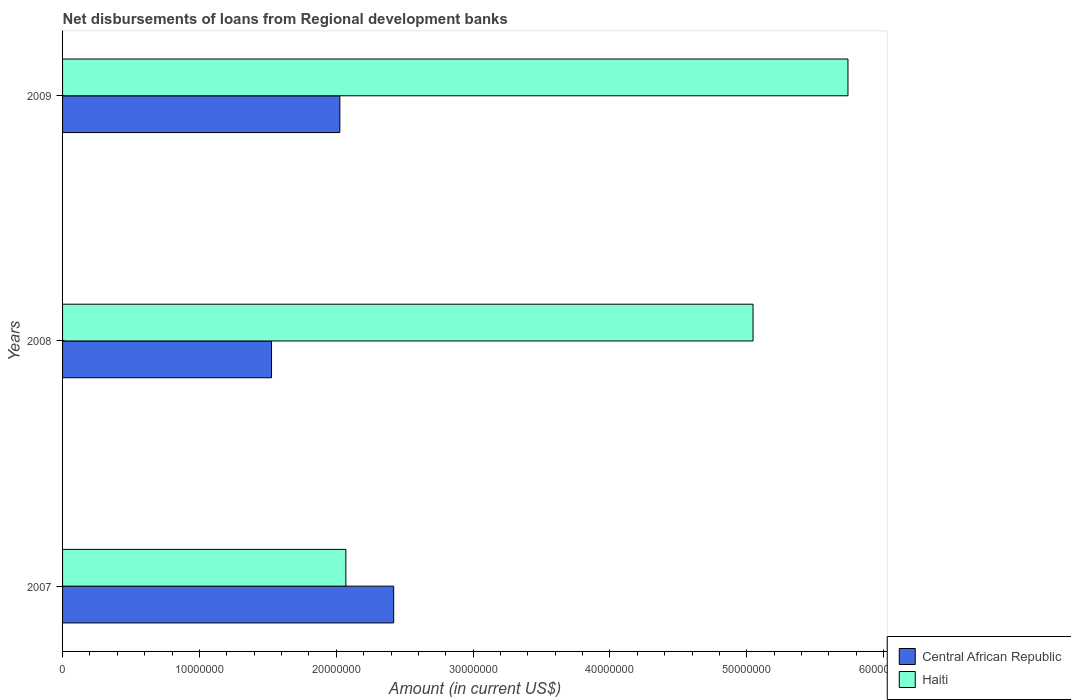Are the number of bars on each tick of the Y-axis equal?
Give a very brief answer. Yes. How many bars are there on the 3rd tick from the bottom?
Your answer should be very brief. 2. What is the label of the 3rd group of bars from the top?
Your answer should be compact. 2007. What is the amount of disbursements of loans from regional development banks in Haiti in 2009?
Make the answer very short. 5.74e+07. Across all years, what is the maximum amount of disbursements of loans from regional development banks in Central African Republic?
Offer a very short reply. 2.42e+07. Across all years, what is the minimum amount of disbursements of loans from regional development banks in Central African Republic?
Give a very brief answer. 1.53e+07. In which year was the amount of disbursements of loans from regional development banks in Central African Republic minimum?
Keep it short and to the point. 2008. What is the total amount of disbursements of loans from regional development banks in Haiti in the graph?
Offer a very short reply. 1.29e+08. What is the difference between the amount of disbursements of loans from regional development banks in Central African Republic in 2007 and that in 2009?
Ensure brevity in your answer.  3.93e+06. What is the difference between the amount of disbursements of loans from regional development banks in Central African Republic in 2009 and the amount of disbursements of loans from regional development banks in Haiti in 2007?
Make the answer very short. -4.41e+05. What is the average amount of disbursements of loans from regional development banks in Haiti per year?
Provide a short and direct response. 4.28e+07. In the year 2008, what is the difference between the amount of disbursements of loans from regional development banks in Central African Republic and amount of disbursements of loans from regional development banks in Haiti?
Offer a very short reply. -3.52e+07. In how many years, is the amount of disbursements of loans from regional development banks in Central African Republic greater than 42000000 US$?
Ensure brevity in your answer.  0. What is the ratio of the amount of disbursements of loans from regional development banks in Haiti in 2007 to that in 2008?
Your answer should be compact. 0.41. Is the amount of disbursements of loans from regional development banks in Central African Republic in 2007 less than that in 2009?
Give a very brief answer. No. Is the difference between the amount of disbursements of loans from regional development banks in Central African Republic in 2007 and 2008 greater than the difference between the amount of disbursements of loans from regional development banks in Haiti in 2007 and 2008?
Your response must be concise. Yes. What is the difference between the highest and the second highest amount of disbursements of loans from regional development banks in Haiti?
Ensure brevity in your answer.  6.94e+06. What is the difference between the highest and the lowest amount of disbursements of loans from regional development banks in Central African Republic?
Your answer should be compact. 8.92e+06. What does the 1st bar from the top in 2009 represents?
Offer a very short reply. Haiti. What does the 2nd bar from the bottom in 2009 represents?
Keep it short and to the point. Haiti. How many bars are there?
Provide a short and direct response. 6. Are all the bars in the graph horizontal?
Provide a succinct answer. Yes. How many years are there in the graph?
Offer a very short reply. 3. Does the graph contain any zero values?
Your answer should be very brief. No. Where does the legend appear in the graph?
Offer a terse response. Bottom right. How many legend labels are there?
Offer a very short reply. 2. What is the title of the graph?
Your response must be concise. Net disbursements of loans from Regional development banks. Does "Switzerland" appear as one of the legend labels in the graph?
Your response must be concise. No. What is the label or title of the X-axis?
Keep it short and to the point. Amount (in current US$). What is the label or title of the Y-axis?
Ensure brevity in your answer.  Years. What is the Amount (in current US$) in Central African Republic in 2007?
Keep it short and to the point. 2.42e+07. What is the Amount (in current US$) in Haiti in 2007?
Keep it short and to the point. 2.07e+07. What is the Amount (in current US$) of Central African Republic in 2008?
Provide a short and direct response. 1.53e+07. What is the Amount (in current US$) of Haiti in 2008?
Offer a terse response. 5.05e+07. What is the Amount (in current US$) in Central African Republic in 2009?
Your answer should be very brief. 2.03e+07. What is the Amount (in current US$) in Haiti in 2009?
Offer a very short reply. 5.74e+07. Across all years, what is the maximum Amount (in current US$) in Central African Republic?
Ensure brevity in your answer.  2.42e+07. Across all years, what is the maximum Amount (in current US$) in Haiti?
Your answer should be compact. 5.74e+07. Across all years, what is the minimum Amount (in current US$) in Central African Republic?
Make the answer very short. 1.53e+07. Across all years, what is the minimum Amount (in current US$) of Haiti?
Offer a terse response. 2.07e+07. What is the total Amount (in current US$) of Central African Republic in the graph?
Make the answer very short. 5.97e+07. What is the total Amount (in current US$) of Haiti in the graph?
Offer a very short reply. 1.29e+08. What is the difference between the Amount (in current US$) in Central African Republic in 2007 and that in 2008?
Offer a terse response. 8.92e+06. What is the difference between the Amount (in current US$) of Haiti in 2007 and that in 2008?
Your response must be concise. -2.98e+07. What is the difference between the Amount (in current US$) of Central African Republic in 2007 and that in 2009?
Offer a very short reply. 3.93e+06. What is the difference between the Amount (in current US$) of Haiti in 2007 and that in 2009?
Make the answer very short. -3.67e+07. What is the difference between the Amount (in current US$) of Central African Republic in 2008 and that in 2009?
Ensure brevity in your answer.  -4.99e+06. What is the difference between the Amount (in current US$) in Haiti in 2008 and that in 2009?
Keep it short and to the point. -6.94e+06. What is the difference between the Amount (in current US$) of Central African Republic in 2007 and the Amount (in current US$) of Haiti in 2008?
Your answer should be compact. -2.63e+07. What is the difference between the Amount (in current US$) of Central African Republic in 2007 and the Amount (in current US$) of Haiti in 2009?
Offer a terse response. -3.32e+07. What is the difference between the Amount (in current US$) of Central African Republic in 2008 and the Amount (in current US$) of Haiti in 2009?
Your answer should be very brief. -4.21e+07. What is the average Amount (in current US$) in Central African Republic per year?
Provide a succinct answer. 1.99e+07. What is the average Amount (in current US$) in Haiti per year?
Offer a very short reply. 4.28e+07. In the year 2007, what is the difference between the Amount (in current US$) of Central African Republic and Amount (in current US$) of Haiti?
Your answer should be very brief. 3.49e+06. In the year 2008, what is the difference between the Amount (in current US$) of Central African Republic and Amount (in current US$) of Haiti?
Keep it short and to the point. -3.52e+07. In the year 2009, what is the difference between the Amount (in current US$) in Central African Republic and Amount (in current US$) in Haiti?
Offer a very short reply. -3.71e+07. What is the ratio of the Amount (in current US$) in Central African Republic in 2007 to that in 2008?
Your answer should be compact. 1.58. What is the ratio of the Amount (in current US$) in Haiti in 2007 to that in 2008?
Your answer should be very brief. 0.41. What is the ratio of the Amount (in current US$) in Central African Republic in 2007 to that in 2009?
Offer a terse response. 1.19. What is the ratio of the Amount (in current US$) of Haiti in 2007 to that in 2009?
Your answer should be very brief. 0.36. What is the ratio of the Amount (in current US$) of Central African Republic in 2008 to that in 2009?
Make the answer very short. 0.75. What is the ratio of the Amount (in current US$) in Haiti in 2008 to that in 2009?
Your answer should be very brief. 0.88. What is the difference between the highest and the second highest Amount (in current US$) in Central African Republic?
Your response must be concise. 3.93e+06. What is the difference between the highest and the second highest Amount (in current US$) in Haiti?
Your answer should be very brief. 6.94e+06. What is the difference between the highest and the lowest Amount (in current US$) of Central African Republic?
Your answer should be compact. 8.92e+06. What is the difference between the highest and the lowest Amount (in current US$) of Haiti?
Keep it short and to the point. 3.67e+07. 